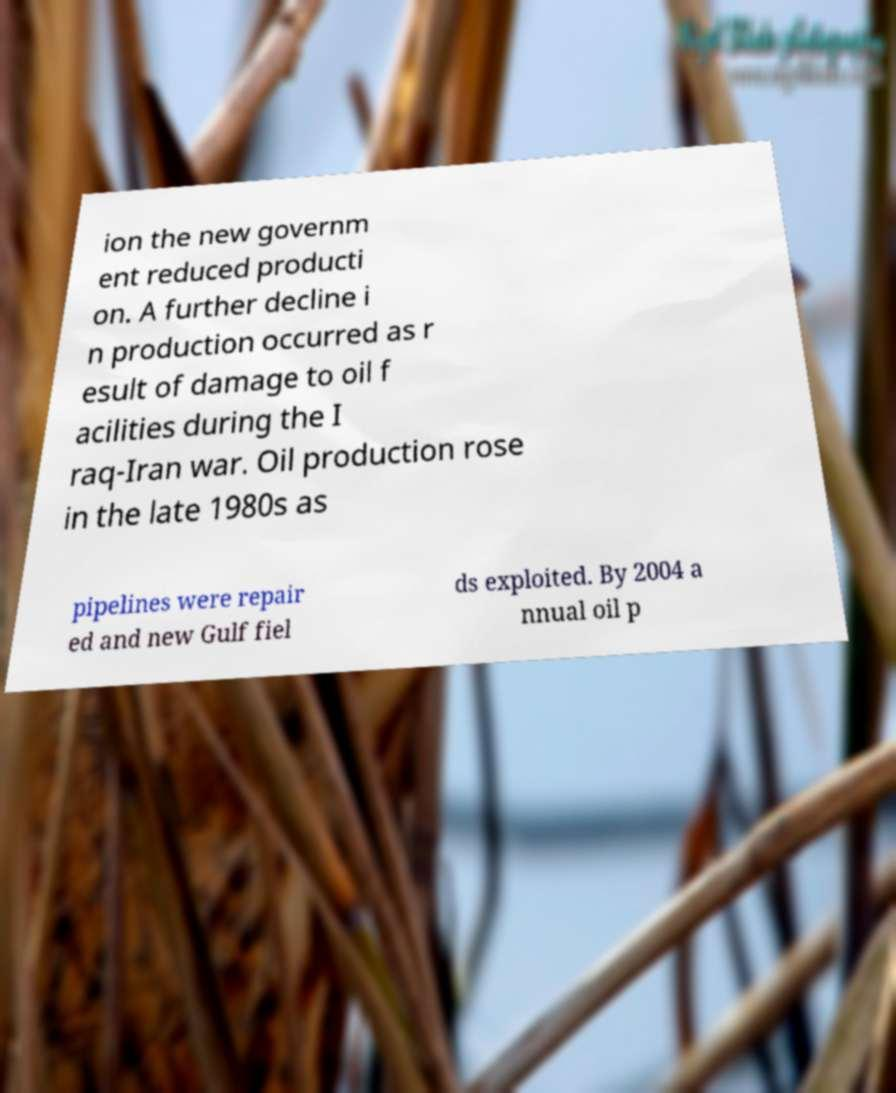I need the written content from this picture converted into text. Can you do that? ion the new governm ent reduced producti on. A further decline i n production occurred as r esult of damage to oil f acilities during the I raq-Iran war. Oil production rose in the late 1980s as pipelines were repair ed and new Gulf fiel ds exploited. By 2004 a nnual oil p 